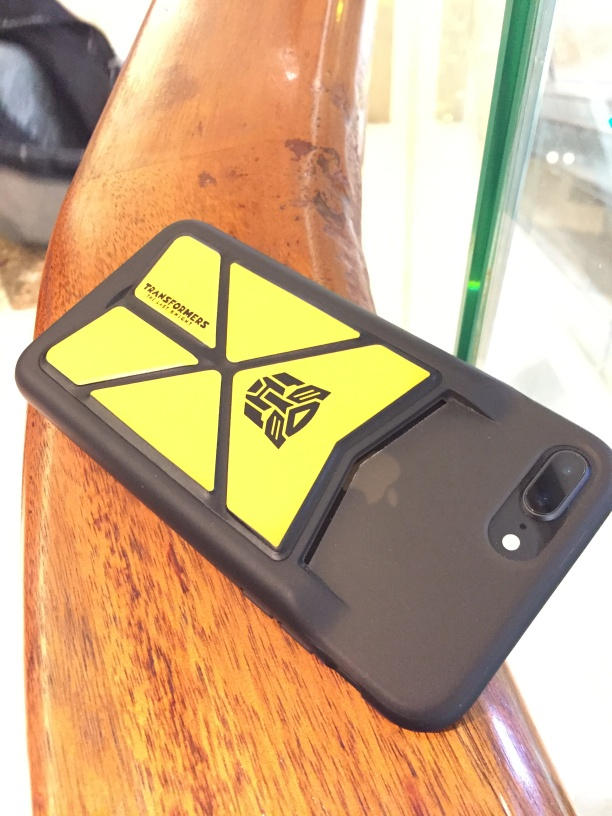What is this object and what does the symbol represent? This is a smartphone in a protective case. The symbol on the case resembles a stylized emblem, possibly representing a company logo or a personal emblem related to the interests of the phone's owner. 